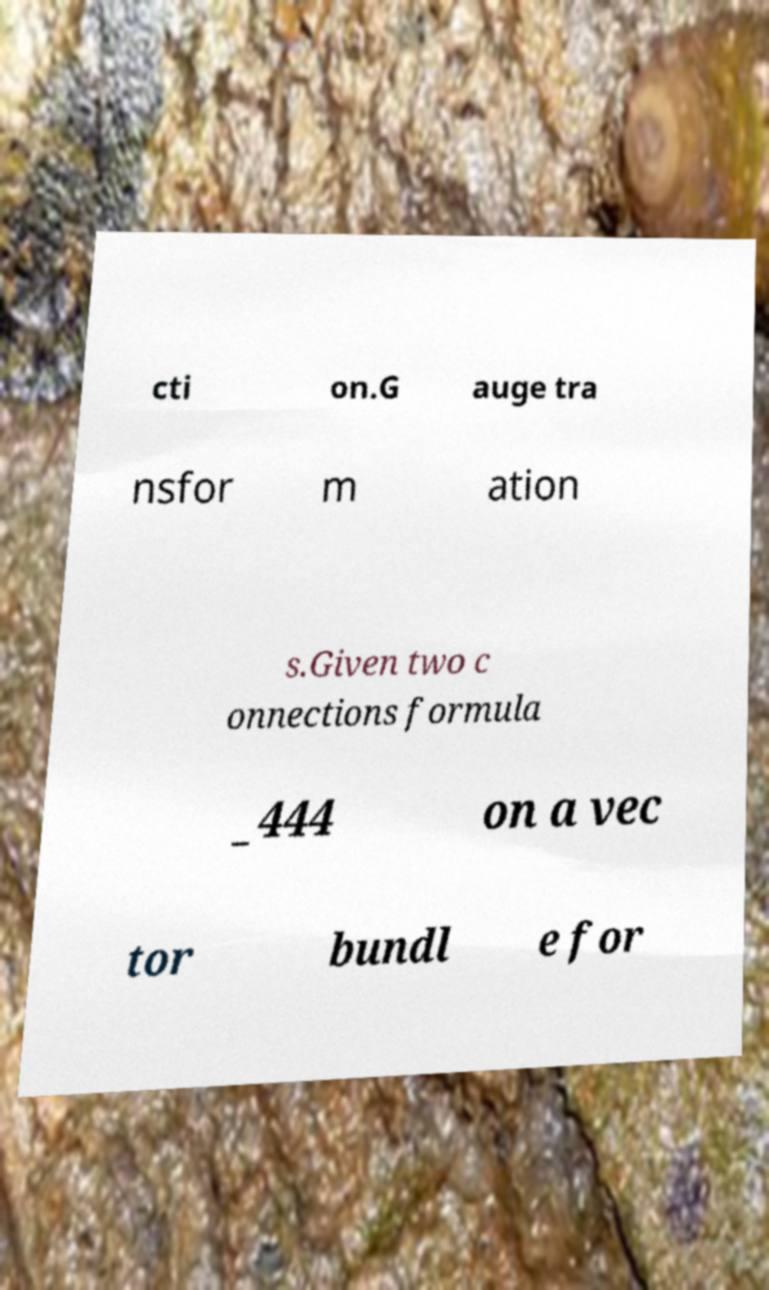For documentation purposes, I need the text within this image transcribed. Could you provide that? cti on.G auge tra nsfor m ation s.Given two c onnections formula _444 on a vec tor bundl e for 